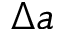<formula> <loc_0><loc_0><loc_500><loc_500>\Delta a</formula> 